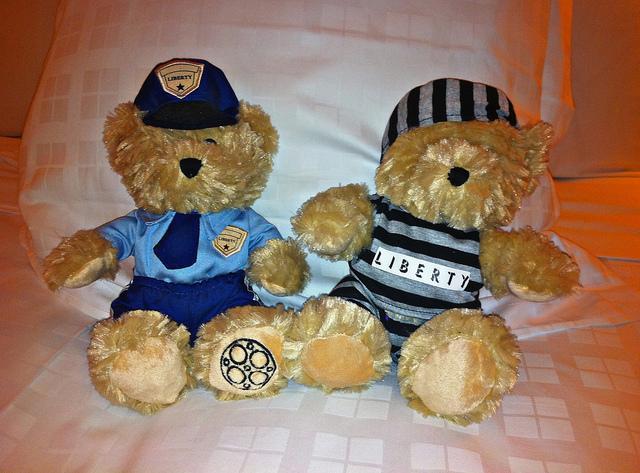How many eyes are in the picture?
Give a very brief answer. 1. How many teddy bears are there?
Give a very brief answer. 2. How many men are standing on the left?
Give a very brief answer. 0. 